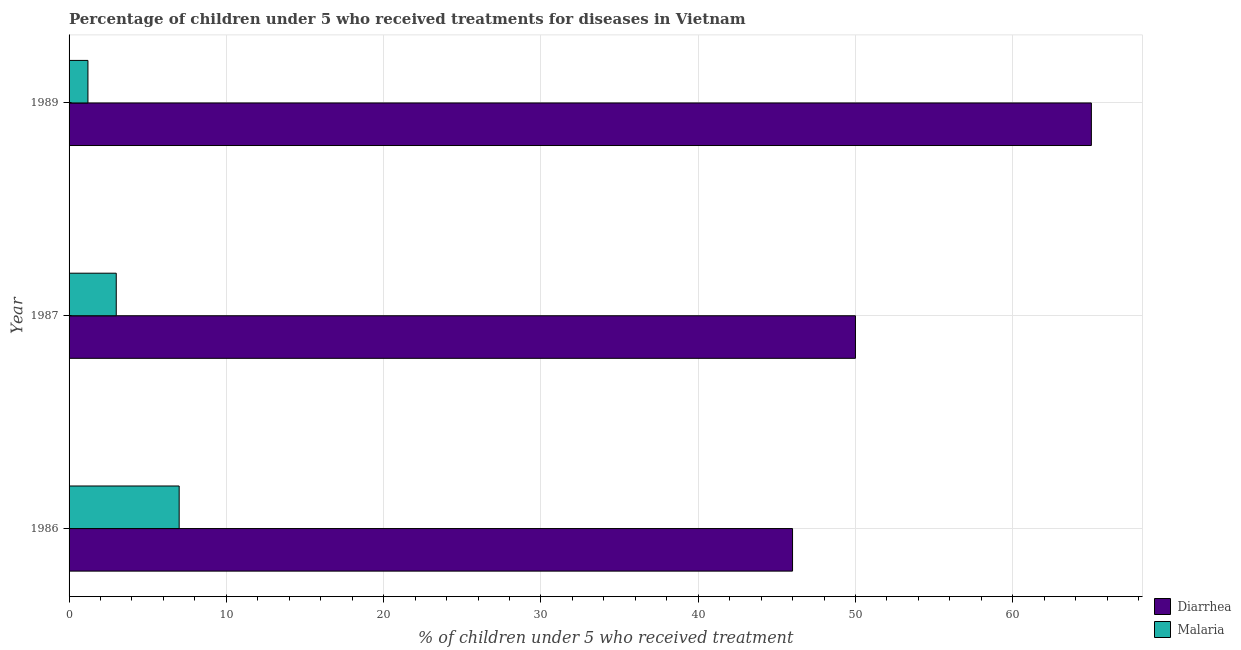How many different coloured bars are there?
Provide a short and direct response. 2. How many groups of bars are there?
Make the answer very short. 3. Are the number of bars per tick equal to the number of legend labels?
Make the answer very short. Yes. Are the number of bars on each tick of the Y-axis equal?
Provide a short and direct response. Yes. How many bars are there on the 3rd tick from the bottom?
Keep it short and to the point. 2. What is the label of the 1st group of bars from the top?
Offer a very short reply. 1989. In how many cases, is the number of bars for a given year not equal to the number of legend labels?
Make the answer very short. 0. What is the percentage of children who received treatment for diarrhoea in 1989?
Offer a terse response. 65. Across all years, what is the maximum percentage of children who received treatment for diarrhoea?
Your answer should be very brief. 65. Across all years, what is the minimum percentage of children who received treatment for malaria?
Provide a succinct answer. 1.2. In which year was the percentage of children who received treatment for diarrhoea minimum?
Your response must be concise. 1986. What is the total percentage of children who received treatment for diarrhoea in the graph?
Offer a terse response. 161. What is the difference between the percentage of children who received treatment for malaria in 1986 and that in 1989?
Your answer should be compact. 5.8. What is the difference between the percentage of children who received treatment for malaria in 1986 and the percentage of children who received treatment for diarrhoea in 1989?
Make the answer very short. -58. What is the average percentage of children who received treatment for diarrhoea per year?
Offer a terse response. 53.67. In the year 1989, what is the difference between the percentage of children who received treatment for malaria and percentage of children who received treatment for diarrhoea?
Offer a very short reply. -63.8. What is the ratio of the percentage of children who received treatment for malaria in 1987 to that in 1989?
Provide a short and direct response. 2.5. Is the percentage of children who received treatment for diarrhoea in 1987 less than that in 1989?
Keep it short and to the point. Yes. Is the difference between the percentage of children who received treatment for malaria in 1986 and 1989 greater than the difference between the percentage of children who received treatment for diarrhoea in 1986 and 1989?
Give a very brief answer. Yes. What is the difference between the highest and the second highest percentage of children who received treatment for malaria?
Make the answer very short. 4. What is the difference between the highest and the lowest percentage of children who received treatment for diarrhoea?
Give a very brief answer. 19. In how many years, is the percentage of children who received treatment for diarrhoea greater than the average percentage of children who received treatment for diarrhoea taken over all years?
Your answer should be compact. 1. What does the 2nd bar from the top in 1989 represents?
Provide a short and direct response. Diarrhea. What does the 1st bar from the bottom in 1986 represents?
Offer a very short reply. Diarrhea. How many bars are there?
Keep it short and to the point. 6. Are the values on the major ticks of X-axis written in scientific E-notation?
Provide a short and direct response. No. Does the graph contain any zero values?
Your answer should be very brief. No. Where does the legend appear in the graph?
Provide a short and direct response. Bottom right. How many legend labels are there?
Provide a succinct answer. 2. How are the legend labels stacked?
Your answer should be very brief. Vertical. What is the title of the graph?
Provide a succinct answer. Percentage of children under 5 who received treatments for diseases in Vietnam. What is the label or title of the X-axis?
Your answer should be very brief. % of children under 5 who received treatment. What is the label or title of the Y-axis?
Your response must be concise. Year. What is the % of children under 5 who received treatment of Malaria in 1987?
Your answer should be compact. 3. What is the % of children under 5 who received treatment of Diarrhea in 1989?
Give a very brief answer. 65. What is the % of children under 5 who received treatment of Malaria in 1989?
Provide a short and direct response. 1.2. Across all years, what is the maximum % of children under 5 who received treatment of Malaria?
Your response must be concise. 7. What is the total % of children under 5 who received treatment of Diarrhea in the graph?
Your answer should be very brief. 161. What is the difference between the % of children under 5 who received treatment of Diarrhea in 1986 and that in 1987?
Keep it short and to the point. -4. What is the difference between the % of children under 5 who received treatment of Diarrhea in 1986 and the % of children under 5 who received treatment of Malaria in 1989?
Provide a succinct answer. 44.8. What is the difference between the % of children under 5 who received treatment of Diarrhea in 1987 and the % of children under 5 who received treatment of Malaria in 1989?
Your answer should be very brief. 48.8. What is the average % of children under 5 who received treatment in Diarrhea per year?
Your answer should be compact. 53.67. What is the average % of children under 5 who received treatment in Malaria per year?
Provide a succinct answer. 3.73. In the year 1987, what is the difference between the % of children under 5 who received treatment of Diarrhea and % of children under 5 who received treatment of Malaria?
Make the answer very short. 47. In the year 1989, what is the difference between the % of children under 5 who received treatment of Diarrhea and % of children under 5 who received treatment of Malaria?
Offer a terse response. 63.8. What is the ratio of the % of children under 5 who received treatment in Diarrhea in 1986 to that in 1987?
Give a very brief answer. 0.92. What is the ratio of the % of children under 5 who received treatment of Malaria in 1986 to that in 1987?
Make the answer very short. 2.33. What is the ratio of the % of children under 5 who received treatment of Diarrhea in 1986 to that in 1989?
Your response must be concise. 0.71. What is the ratio of the % of children under 5 who received treatment of Malaria in 1986 to that in 1989?
Your answer should be compact. 5.83. What is the ratio of the % of children under 5 who received treatment in Diarrhea in 1987 to that in 1989?
Make the answer very short. 0.77. What is the ratio of the % of children under 5 who received treatment in Malaria in 1987 to that in 1989?
Your answer should be very brief. 2.5. What is the difference between the highest and the second highest % of children under 5 who received treatment in Malaria?
Ensure brevity in your answer.  4. What is the difference between the highest and the lowest % of children under 5 who received treatment in Malaria?
Offer a terse response. 5.8. 